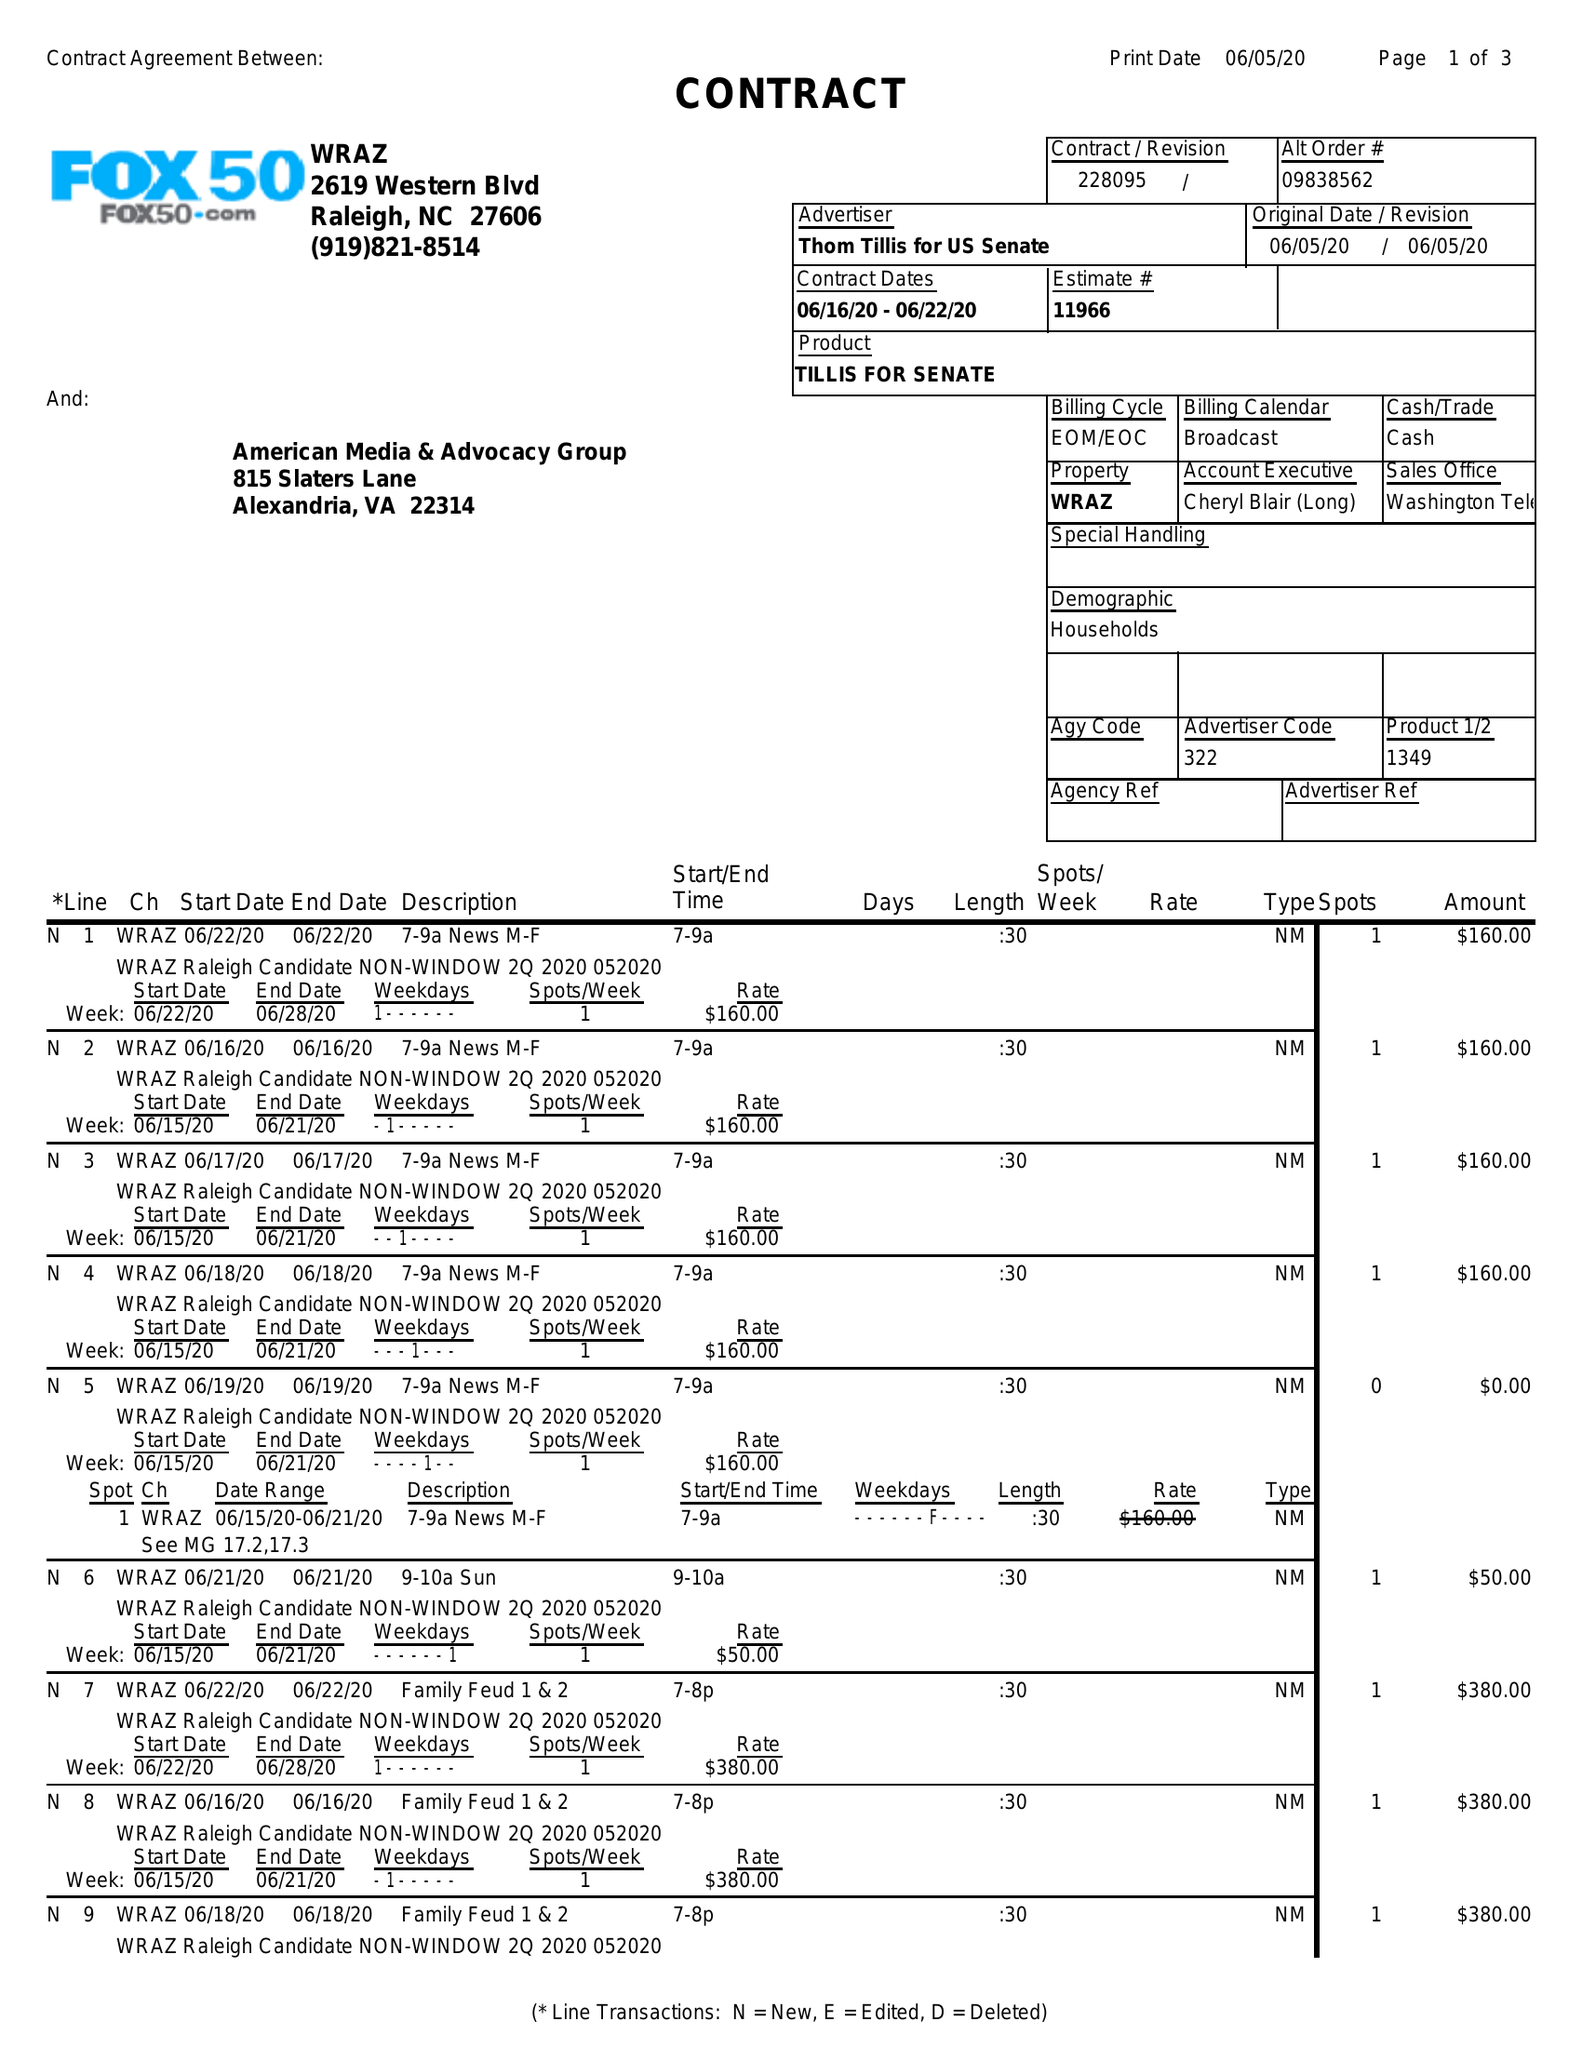What is the value for the gross_amount?
Answer the question using a single word or phrase. 7770.00 